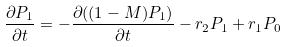<formula> <loc_0><loc_0><loc_500><loc_500>\frac { \partial P _ { 1 } } { \partial t } = - \frac { \partial ( ( 1 - M ) P _ { 1 } ) } { \partial t } - r _ { 2 } P _ { 1 } + r _ { 1 } P _ { 0 }</formula> 